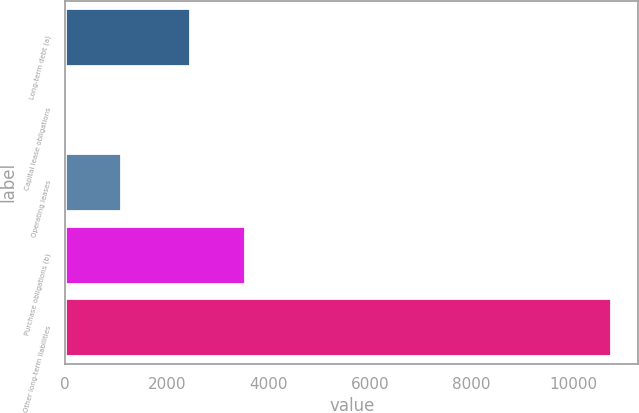Convert chart. <chart><loc_0><loc_0><loc_500><loc_500><bar_chart><fcel>Long-term debt (a)<fcel>Capital lease obligations<fcel>Operating leases<fcel>Purchase obligations (b)<fcel>Other long-term liabilities<nl><fcel>2464<fcel>22<fcel>1094.8<fcel>3536.8<fcel>10750<nl></chart> 